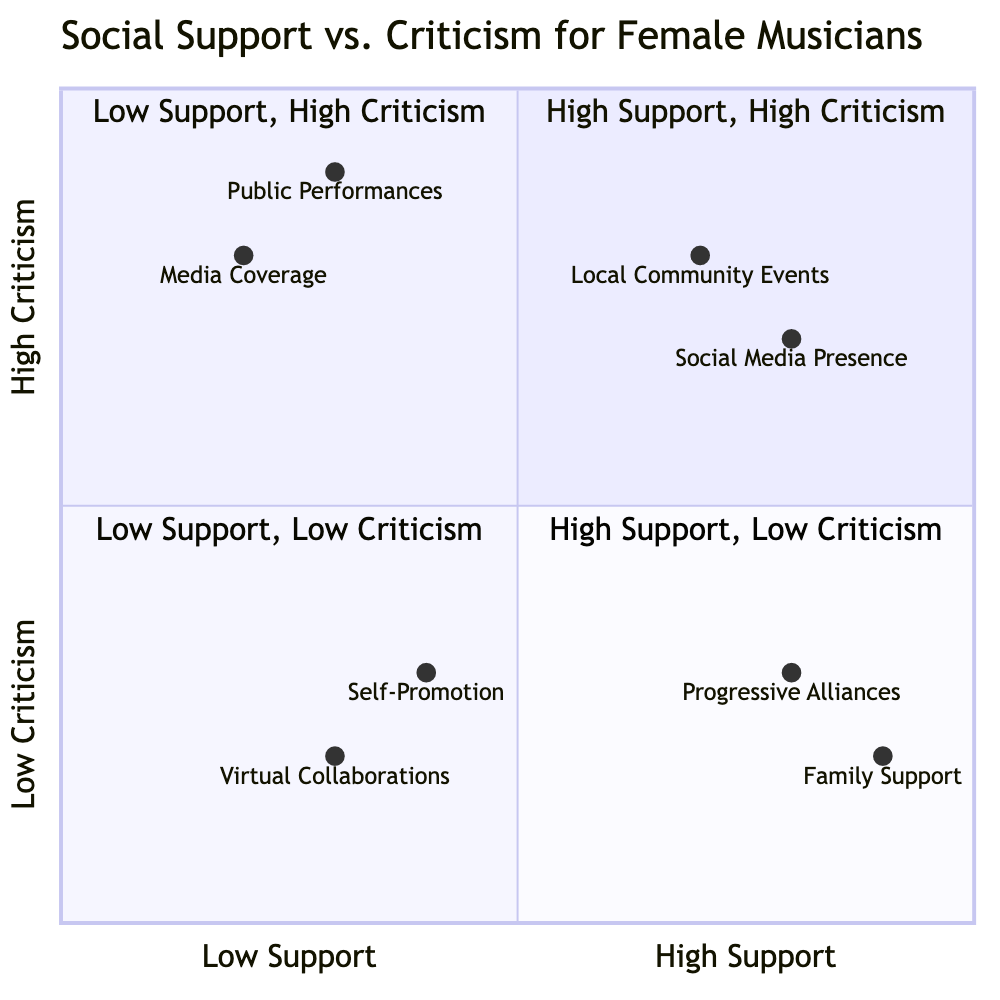What are the elements in the High Support, High Criticism quadrant? The High Support, High Criticism quadrant contains Local Community Events and Social Media Presence.
Answer: Local Community Events, Social Media Presence Which element has the highest support rating? Family Support has the highest support rating at 0.9.
Answer: Family Support How many elements are in the Low Support, High Criticism quadrant? There are two elements in the Low Support, High Criticism quadrant: Public Performances and Media Coverage.
Answer: 2 What is the criticism level of Progressive Alliances? The criticism level of Progressive Alliances is 0.3.
Answer: 0.3 Which quadrant contains elements with low support and low criticism? The Low Support, Low Criticism quadrant contains elements like Self-Promotion and Virtual Collaborations.
Answer: Low Support, Low Criticism Which element is most likely to face criticism during a public performance? Public Performances is most likely to face criticism from conservative community members.
Answer: Public Performances What is the relationship between Social Media Presence and local criticism? Social Media Presence is associated with high support and considerable local criticism.
Answer: High support, considerable local criticism Which element in the diagram has the least community reaction? Virtual Collaborations has the least community reaction as it refers to online collaborations without significant local attention.
Answer: Virtual Collaborations 